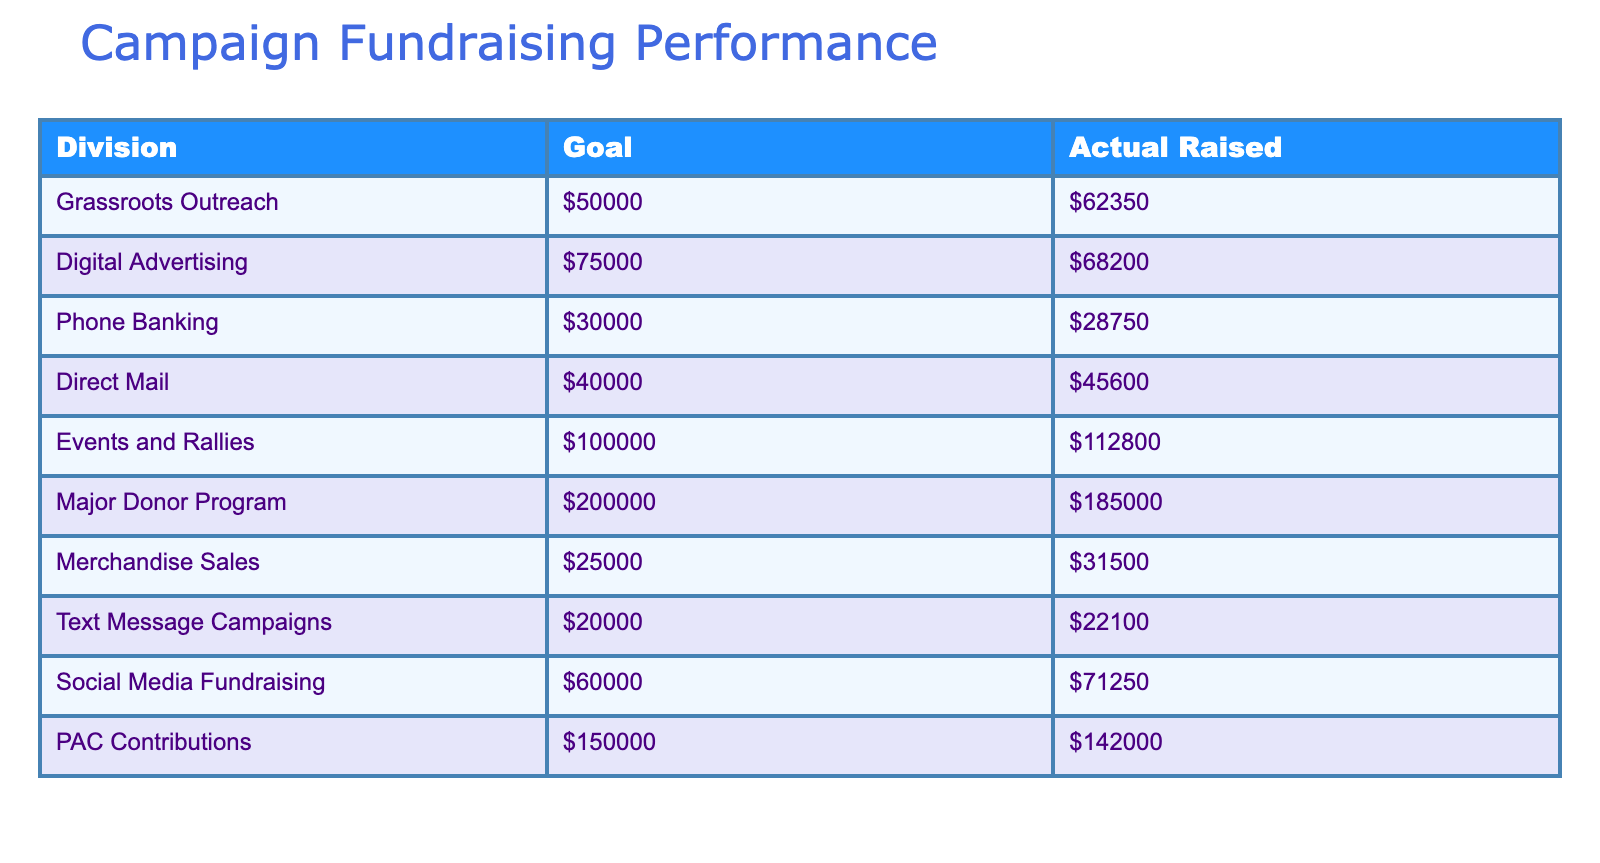What is the actual amount raised by Grassroots Outreach? The table shows that the actual amount raised by Grassroots Outreach is $62350, which can be found in the "Actual Raised" column corresponding to the "Grassroots Outreach" row.
Answer: $62350 What is the total goal amount for all divisions combined? To find the total goal amount, we sum up all the values in the "Goal" column: $50000 + $75000 + $30000 + $40000 + $100000 + $200000 + $25000 + $20000 + $60000 + $150000 = $400000.
Answer: $400000 Is the actual amount raised by Events and Rallies greater than its goal? The goal for Events and Rallies is $100000, and the actual amount raised is $112800. Since $112800 is greater than $100000, the answer is yes.
Answer: Yes What is the difference between the goal and actual amount raised for the Major Donor Program? The goal for the Major Donor Program is $200000 and the actual raised amount is $185000. The difference is $200000 - $185000 = $15000.
Answer: $15000 Which division exceeded its fundraising goal by the largest amount? By comparing the differences between the goal and actual raised amounts for each division, we find that Events and Rallies exceeded its goal by $12800 ($112800 - $100000), which is the largest excess across all divisions.
Answer: Events and Rallies What is the average actual amount raised across all divisions? There are 10 divisions, and their actual amounts raised are $62350, $68200, $28750, $45600, $112800, $185000, $31500, $22100, $71250, and $142000. Summing these amounts gives $608650, and dividing by 10 (the number of divisions) gives an average of $60865.
Answer: $60865 Did the Digital Advertising division meet its fundraising goal? The goal for Digital Advertising is $75000, and the actual amount raised is $68200. Since $68200 is less than $75000, the answer is no.
Answer: No Which division had the lowest actual amount raised? By reviewing the actual amounts raised for each division, Phone Banking has the lowest amount at $28750 compared to the other divisions.
Answer: Phone Banking 